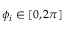<formula> <loc_0><loc_0><loc_500><loc_500>\phi _ { i } \in [ 0 , 2 \pi ]</formula> 